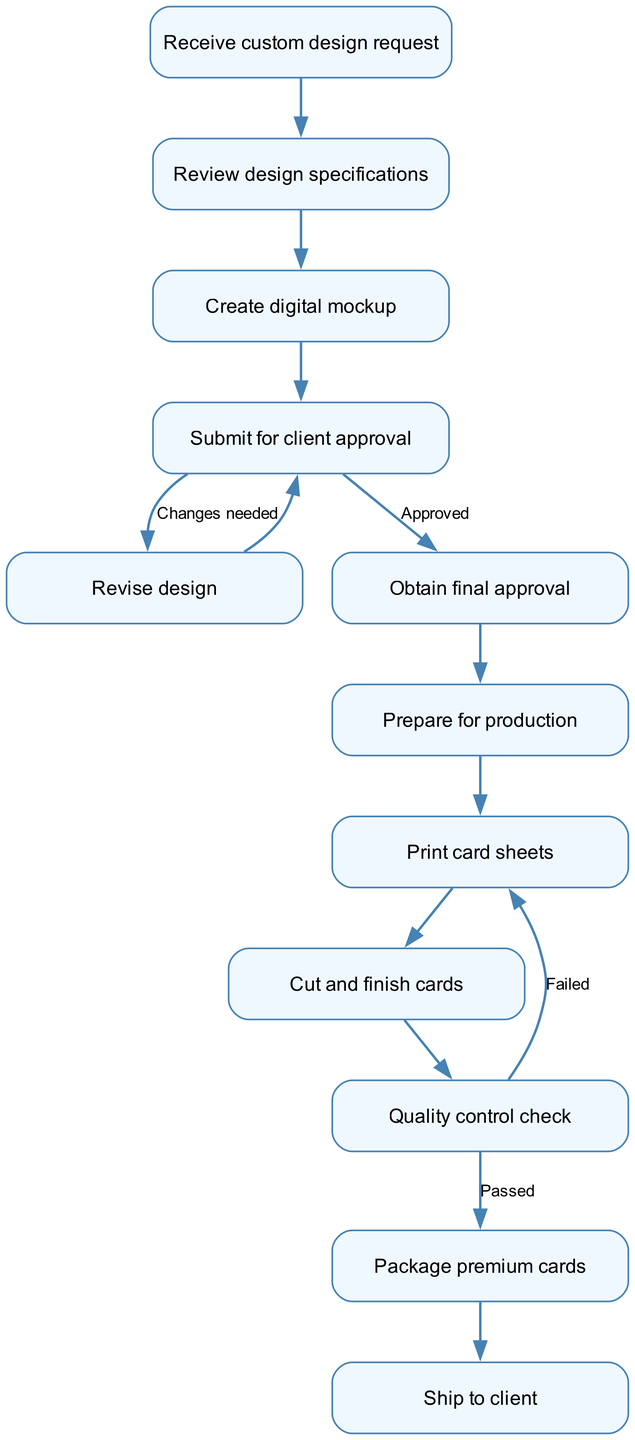What is the first step in the workflow? The first step in the workflow is indicated by the starting node labeled "Receive custom design request." This is the entry point before any other actions take place.
Answer: Receive custom design request How many total nodes are present in the diagram? The total count of nodes is 12, as each unique action or decision point is represented by a distinct node in the diagram.
Answer: 12 What node follows "Client Approval" if it is approved? Following the "Client Approval" node, the next step is "Obtain final approval," which is indicated as the path taken when the design is approved by the client.
Answer: Obtain final approval What happens if the quality control check fails? If the quality control check fails, the process loops back to the "Print card sheets" node, indicating that the printing needs to be redone until the quality meets standards.
Answer: Print card sheets What is the last step in the workflow? The last step of the workflow is "Ship to client," marking the culmination of all prior actions taken to produce the custom playing cards.
Answer: Ship to client Which two nodes are interconnected with a "Changes needed" label? The nodes "Submit for client approval" and "Revise design" are interconnected with the label "Changes needed," indicating that the design must be revised if the client requests modifications.
Answer: Submit for client approval and Revise design What does the workflow indicate happens before preparing for production? The workflow indicates that "Obtain final approval" must happen before "Prepare for production," signifying that the final approval is necessary to proceed to the production stage.
Answer: Obtain final approval How many edges are there connecting the nodes? There are 12 edges connecting the nodes in the diagram, each representing a distinct pathway or relationship between the various steps in the workflow.
Answer: 12 